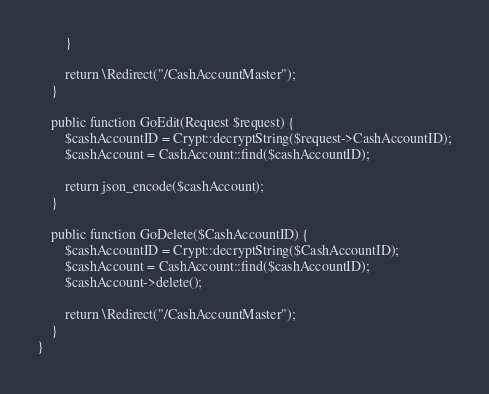Convert code to text. <code><loc_0><loc_0><loc_500><loc_500><_PHP_>        }
        
        return \Redirect("/CashAccountMaster");
    }

    public function GoEdit(Request $request) {
        $cashAccountID = Crypt::decryptString($request->CashAccountID);
        $cashAccount = CashAccount::find($cashAccountID);

        return json_encode($cashAccount);
    }

    public function GoDelete($CashAccountID) {
        $cashAccountID = Crypt::decryptString($CashAccountID);
        $cashAccount = CashAccount::find($cashAccountID);
        $cashAccount->delete();

        return \Redirect("/CashAccountMaster");
    }
}
</code> 